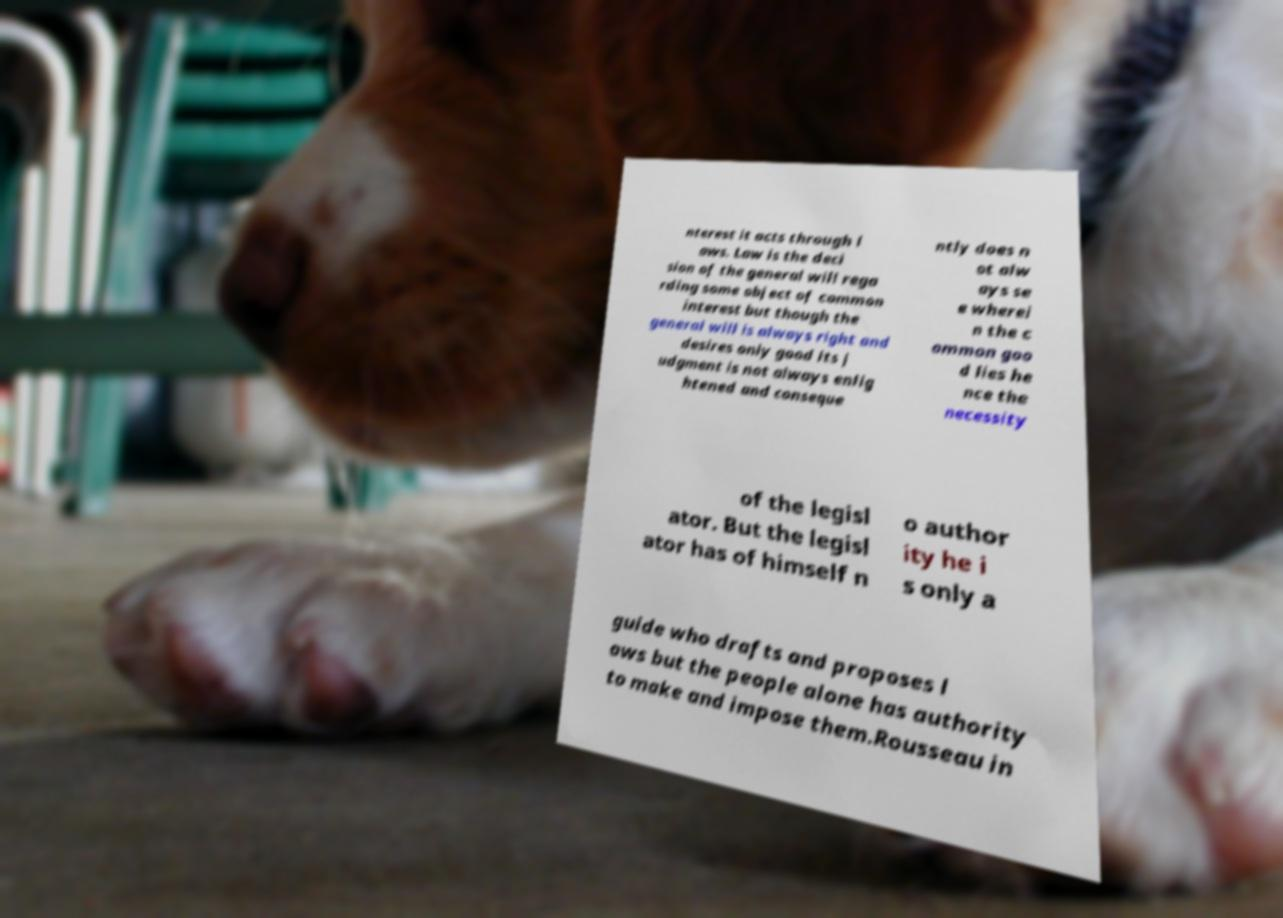What messages or text are displayed in this image? I need them in a readable, typed format. nterest it acts through l aws. Law is the deci sion of the general will rega rding some object of common interest but though the general will is always right and desires only good its j udgment is not always enlig htened and conseque ntly does n ot alw ays se e wherei n the c ommon goo d lies he nce the necessity of the legisl ator. But the legisl ator has of himself n o author ity he i s only a guide who drafts and proposes l aws but the people alone has authority to make and impose them.Rousseau in 